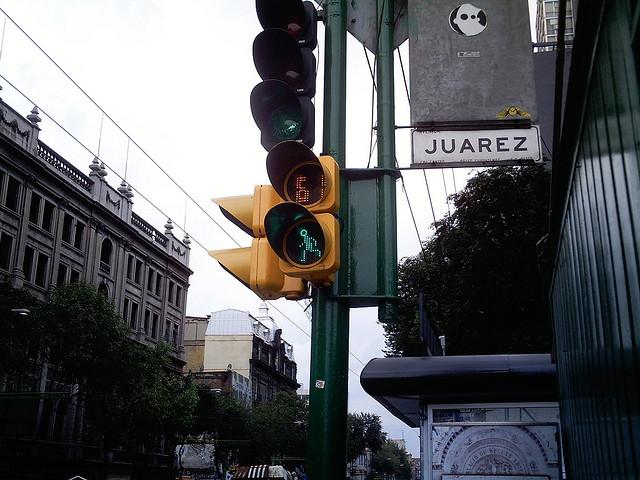What color is the 'walking' light in?
Write a very short answer. Green. How many power lines are overhead?
Answer briefly. 6. Why are there two sets of street lights?
Quick response, please. Pedestrians and cars. 